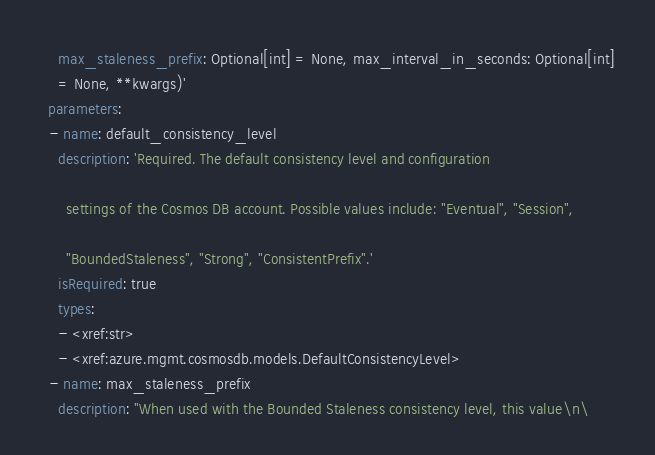<code> <loc_0><loc_0><loc_500><loc_500><_YAML_>    max_staleness_prefix: Optional[int] = None, max_interval_in_seconds: Optional[int]
    = None, **kwargs)'
  parameters:
  - name: default_consistency_level
    description: 'Required. The default consistency level and configuration

      settings of the Cosmos DB account. Possible values include: "Eventual", "Session",

      "BoundedStaleness", "Strong", "ConsistentPrefix".'
    isRequired: true
    types:
    - <xref:str>
    - <xref:azure.mgmt.cosmosdb.models.DefaultConsistencyLevel>
  - name: max_staleness_prefix
    description: "When used with the Bounded Staleness consistency level, this value\n\</code> 